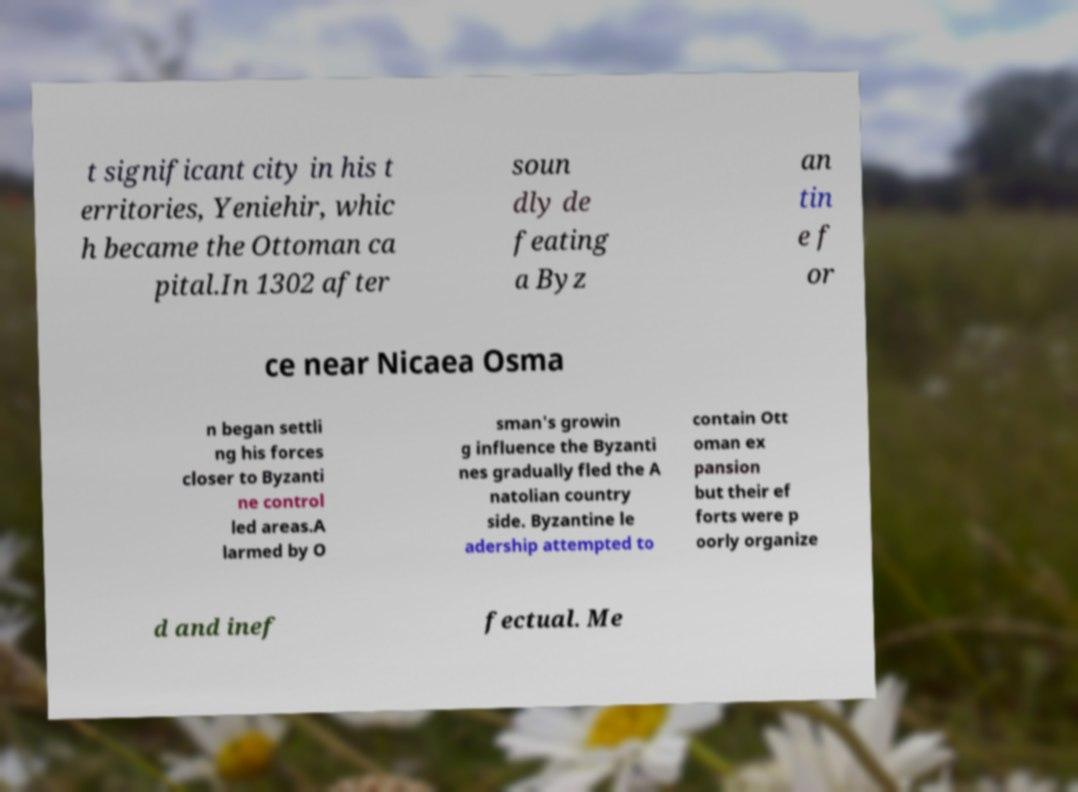Could you assist in decoding the text presented in this image and type it out clearly? t significant city in his t erritories, Yeniehir, whic h became the Ottoman ca pital.In 1302 after soun dly de feating a Byz an tin e f or ce near Nicaea Osma n began settli ng his forces closer to Byzanti ne control led areas.A larmed by O sman's growin g influence the Byzanti nes gradually fled the A natolian country side. Byzantine le adership attempted to contain Ott oman ex pansion but their ef forts were p oorly organize d and inef fectual. Me 